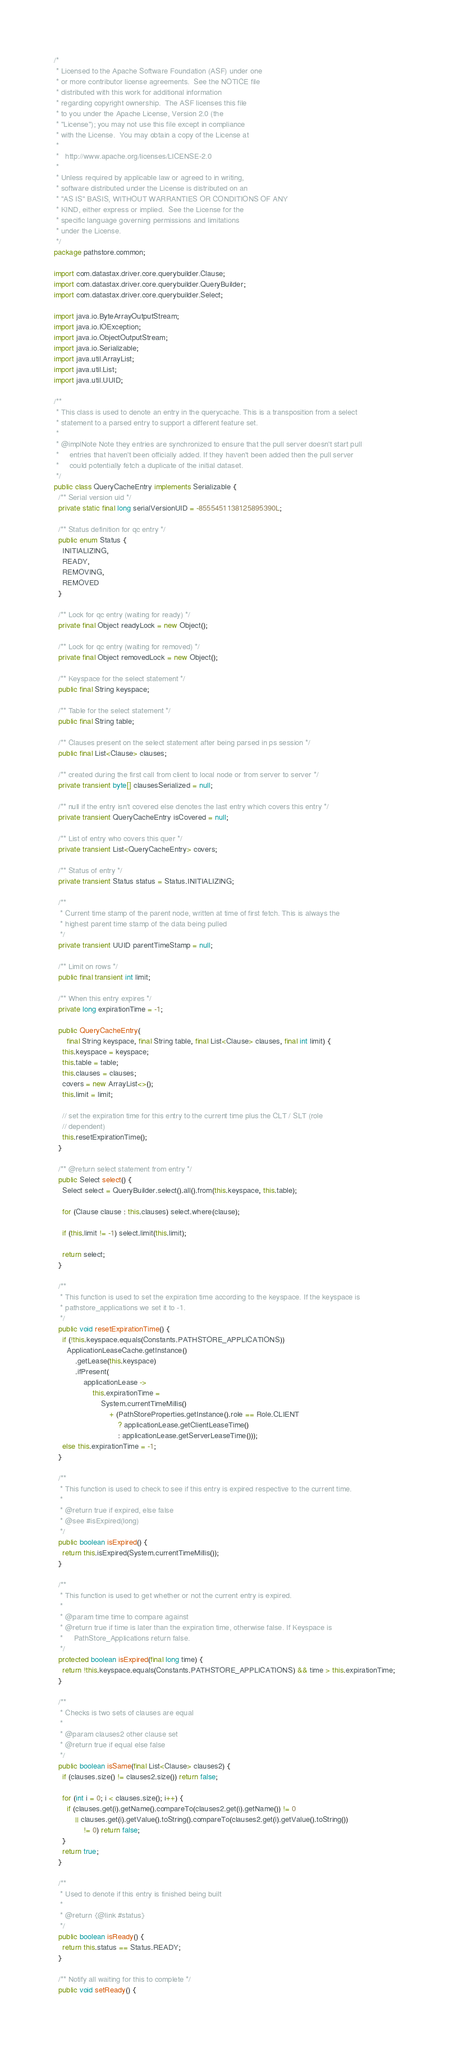<code> <loc_0><loc_0><loc_500><loc_500><_Java_>/*
 * Licensed to the Apache Software Foundation (ASF) under one
 * or more contributor license agreements.  See the NOTICE file
 * distributed with this work for additional information
 * regarding copyright ownership.  The ASF licenses this file
 * to you under the Apache License, Version 2.0 (the
 * "License"); you may not use this file except in compliance
 * with the License.  You may obtain a copy of the License at
 *
 *   http://www.apache.org/licenses/LICENSE-2.0
 *
 * Unless required by applicable law or agreed to in writing,
 * software distributed under the License is distributed on an
 * "AS IS" BASIS, WITHOUT WARRANTIES OR CONDITIONS OF ANY
 * KIND, either express or implied.  See the License for the
 * specific language governing permissions and limitations
 * under the License.
 */
package pathstore.common;

import com.datastax.driver.core.querybuilder.Clause;
import com.datastax.driver.core.querybuilder.QueryBuilder;
import com.datastax.driver.core.querybuilder.Select;

import java.io.ByteArrayOutputStream;
import java.io.IOException;
import java.io.ObjectOutputStream;
import java.io.Serializable;
import java.util.ArrayList;
import java.util.List;
import java.util.UUID;

/**
 * This class is used to denote an entry in the querycache. This is a transposition from a select
 * statement to a parsed entry to support a different feature set.
 *
 * @implNote Note they entries are synchronized to ensure that the pull server doesn't start pull
 *     entries that haven't been officially added. If they haven't been added then the pull server
 *     could potentially fetch a duplicate of the initial dataset.
 */
public class QueryCacheEntry implements Serializable {
  /** Serial version uid */
  private static final long serialVersionUID = -8555451138125895390L;

  /** Status definition for qc entry */
  public enum Status {
    INITIALIZING,
    READY,
    REMOVING,
    REMOVED
  }

  /** Lock for qc entry (waiting for ready) */
  private final Object readyLock = new Object();

  /** Lock for qc entry (waiting for removed) */
  private final Object removedLock = new Object();

  /** Keyspace for the select statement */
  public final String keyspace;

  /** Table for the select statement */
  public final String table;

  /** Clauses present on the select statement after being parsed in ps session */
  public final List<Clause> clauses;

  /** created during the first call from client to local node or from server to server */
  private transient byte[] clausesSerialized = null;

  /** null if the entry isn't covered else denotes the last entry which covers this entry */
  private transient QueryCacheEntry isCovered = null;

  /** List of entry who covers this quer */
  private transient List<QueryCacheEntry> covers;

  /** Status of entry */
  private transient Status status = Status.INITIALIZING;

  /**
   * Current time stamp of the parent node, written at time of first fetch. This is always the
   * highest parent time stamp of the data being pulled
   */
  private transient UUID parentTimeStamp = null;

  /** Limit on rows */
  public final transient int limit;

  /** When this entry expires */
  private long expirationTime = -1;

  public QueryCacheEntry(
      final String keyspace, final String table, final List<Clause> clauses, final int limit) {
    this.keyspace = keyspace;
    this.table = table;
    this.clauses = clauses;
    covers = new ArrayList<>();
    this.limit = limit;

    // set the expiration time for this entry to the current time plus the CLT / SLT (role
    // dependent)
    this.resetExpirationTime();
  }

  /** @return select statement from entry */
  public Select select() {
    Select select = QueryBuilder.select().all().from(this.keyspace, this.table);

    for (Clause clause : this.clauses) select.where(clause);

    if (this.limit != -1) select.limit(this.limit);

    return select;
  }

  /**
   * This function is used to set the expiration time according to the keyspace. If the keyspace is
   * pathstore_applications we set it to -1.
   */
  public void resetExpirationTime() {
    if (!this.keyspace.equals(Constants.PATHSTORE_APPLICATIONS))
      ApplicationLeaseCache.getInstance()
          .getLease(this.keyspace)
          .ifPresent(
              applicationLease ->
                  this.expirationTime =
                      System.currentTimeMillis()
                          + (PathStoreProperties.getInstance().role == Role.CLIENT
                              ? applicationLease.getClientLeaseTime()
                              : applicationLease.getServerLeaseTime()));
    else this.expirationTime = -1;
  }

  /**
   * This function is used to check to see if this entry is expired respective to the current time.
   *
   * @return true if expired, else false
   * @see #isExpired(long)
   */
  public boolean isExpired() {
    return this.isExpired(System.currentTimeMillis());
  }

  /**
   * This function is used to get whether or not the current entry is expired.
   *
   * @param time time to compare against
   * @return true if time is later than the expiration time, otherwise false. If Keyspace is
   *     PathStore_Applications return false.
   */
  protected boolean isExpired(final long time) {
    return !this.keyspace.equals(Constants.PATHSTORE_APPLICATIONS) && time > this.expirationTime;
  }

  /**
   * Checks is two sets of clauses are equal
   *
   * @param clauses2 other clause set
   * @return true if equal else false
   */
  public boolean isSame(final List<Clause> clauses2) {
    if (clauses.size() != clauses2.size()) return false;

    for (int i = 0; i < clauses.size(); i++) {
      if (clauses.get(i).getName().compareTo(clauses2.get(i).getName()) != 0
          || clauses.get(i).getValue().toString().compareTo(clauses2.get(i).getValue().toString())
              != 0) return false;
    }
    return true;
  }

  /**
   * Used to denote if this entry is finished being built
   *
   * @return {@link #status}
   */
  public boolean isReady() {
    return this.status == Status.READY;
  }

  /** Notify all waiting for this to complete */
  public void setReady() {</code> 